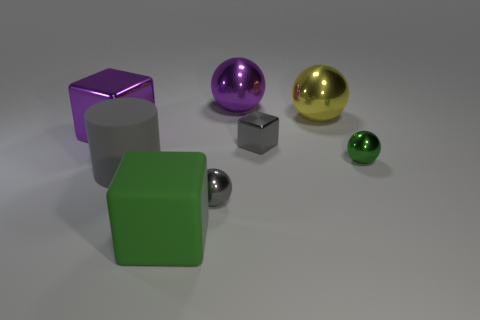Add 1 tiny green metal things. How many objects exist? 9 Subtract all cylinders. How many objects are left? 7 Subtract all small things. Subtract all tiny cyan shiny spheres. How many objects are left? 5 Add 6 big rubber blocks. How many big rubber blocks are left? 7 Add 8 metal cylinders. How many metal cylinders exist? 8 Subtract 0 yellow cubes. How many objects are left? 8 